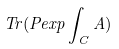<formula> <loc_0><loc_0><loc_500><loc_500>T r ( P e x p \int _ { C } A )</formula> 